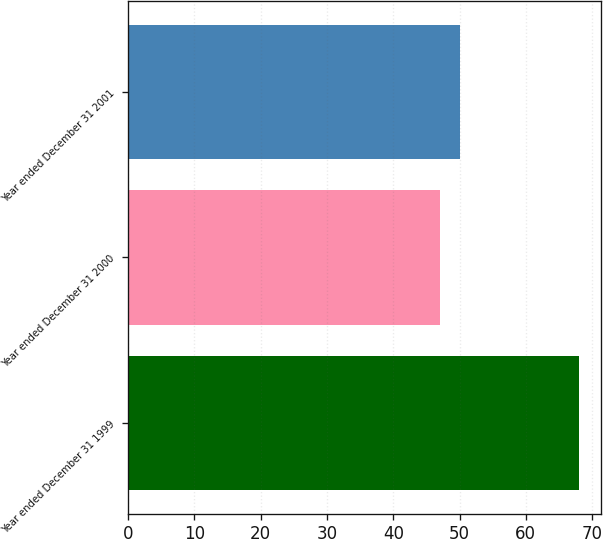Convert chart. <chart><loc_0><loc_0><loc_500><loc_500><bar_chart><fcel>Year ended December 31 1999<fcel>Year ended December 31 2000<fcel>Year ended December 31 2001<nl><fcel>68<fcel>47<fcel>50<nl></chart> 